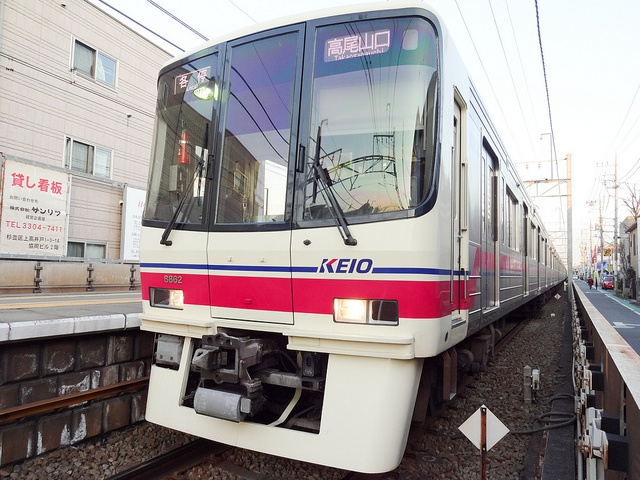Describe the objects in this image and their specific colors. I can see a train in tan, lightgray, darkgray, gray, and black tones in this image. 